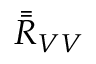Convert formula to latex. <formula><loc_0><loc_0><loc_500><loc_500>\bar { \bar { R } } _ { V V }</formula> 